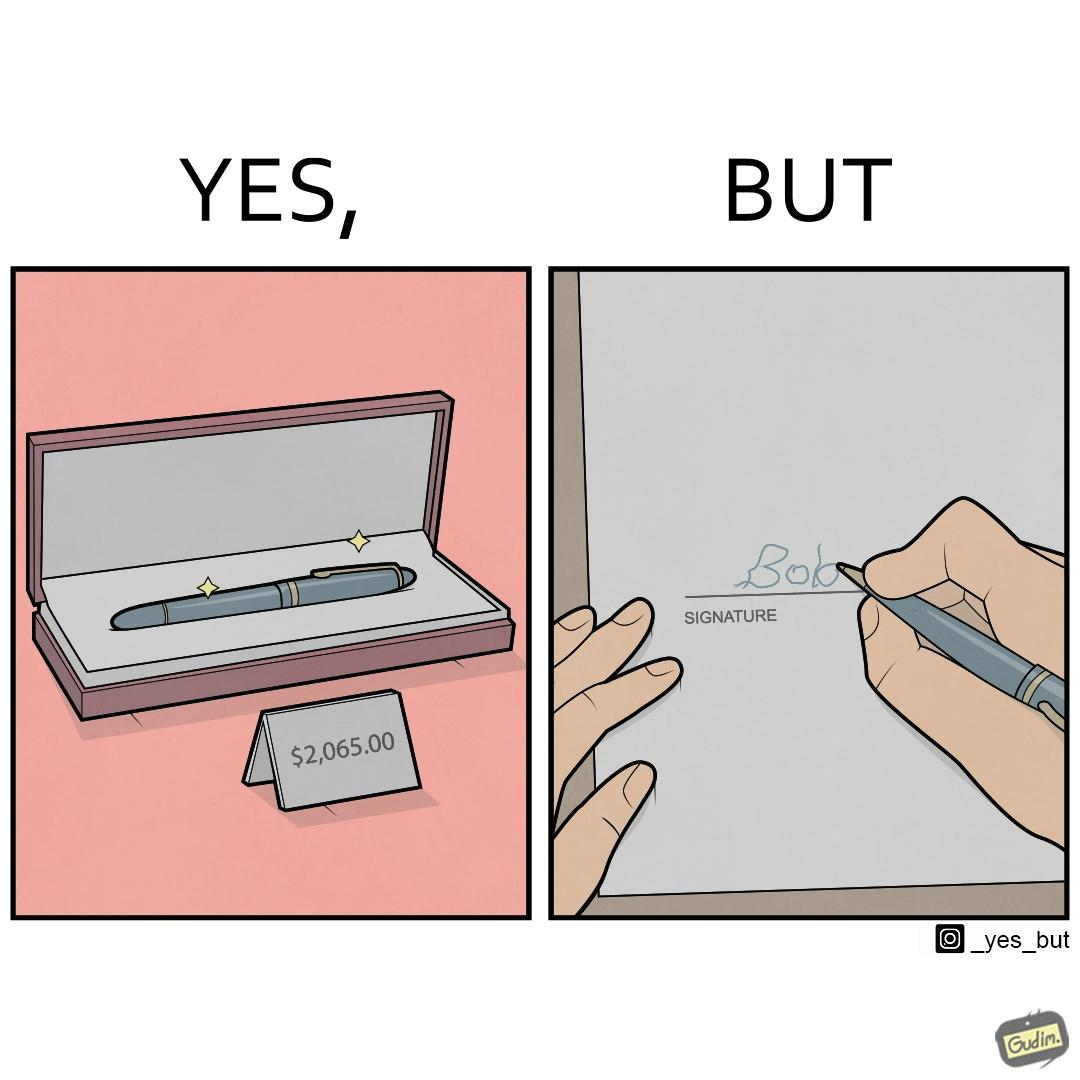What do you see in each half of this image? In the left part of the image: a new sparkling pen at some sale priced at around $2,065.00 In the right part of the image: someone with not so good handwriting giving his signature at some paper 